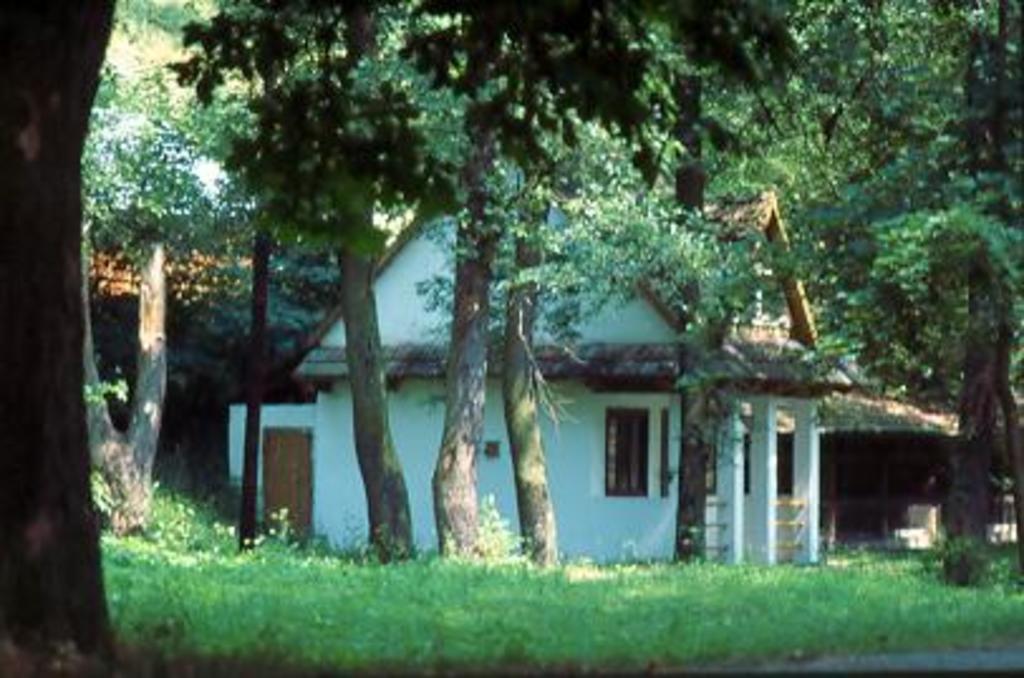Describe this image in one or two sentences. In this image, this looks like a house with the windows and pillars. These are the trees with the branches and leaves. I think this is the grass, which is green in color. 